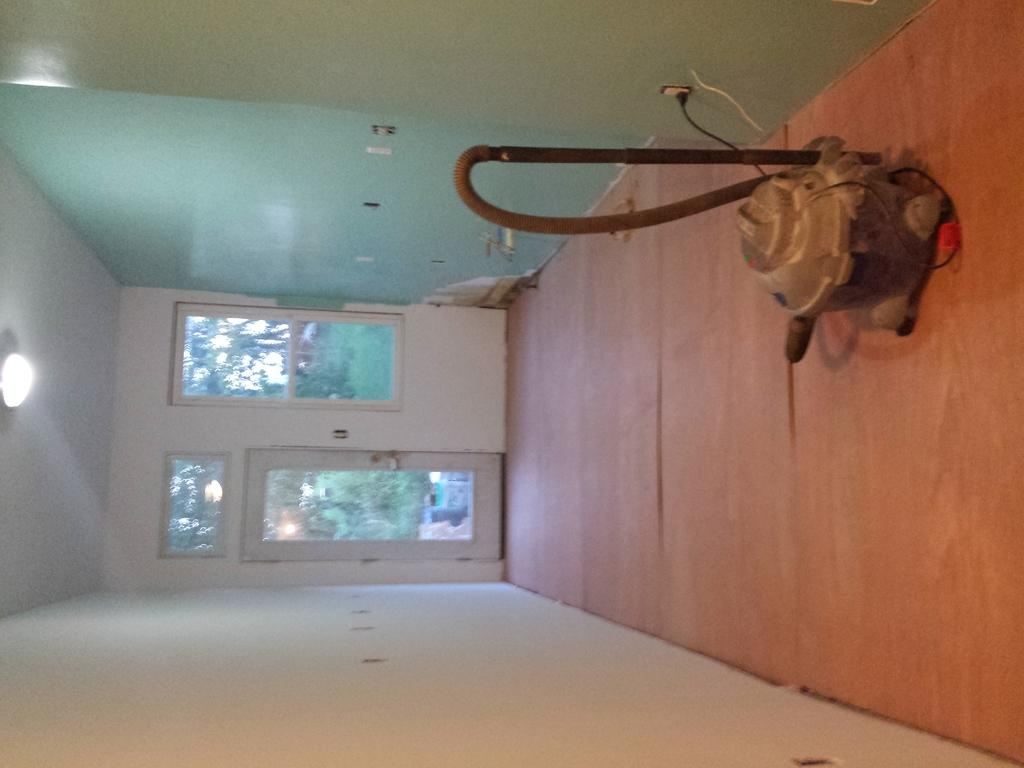What can be seen on the right side of the wall in the image? There is an object on the right side of the wall in the image. What feature is located in the center of the image? There is a window in the center of the image. What is visible outside the window? Trees are visible outside the window. What is located on the left side of the wall in the image? There is a light on the left side of the wall in the image. Where is the stove located in the image? There is no stove present in the image. What type of trees are visible outside the window? The provided facts do not specify the type of trees visible outside the window. 